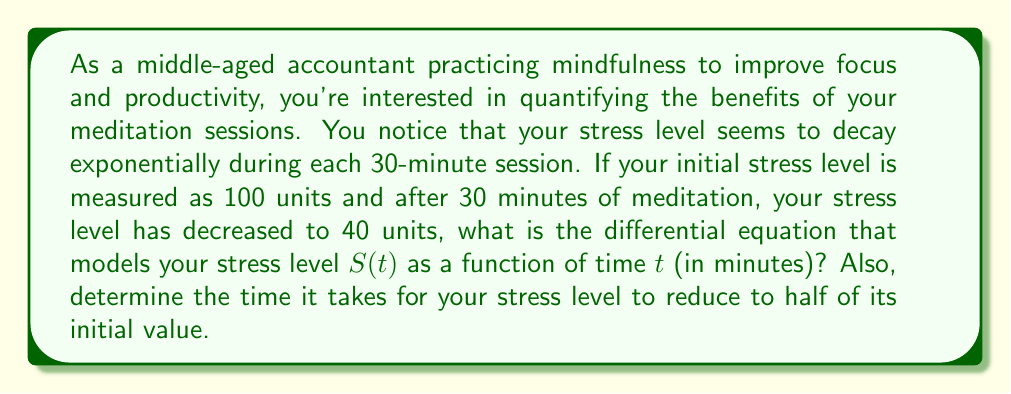Show me your answer to this math problem. Let's approach this step-by-step:

1) First, we need to recognize that this is an exponential decay problem. The general form of an exponential decay equation is:

   $$S(t) = S_0e^{-kt}$$

   where $S_0$ is the initial stress level, $k$ is the decay constant, and $t$ is time.

2) We're given two points:
   At $t = 0$, $S = 100$
   At $t = 30$, $S = 40$

3) Let's use these to find $k$:

   $$40 = 100e^{-k(30)}$$

4) Dividing both sides by 100:

   $$0.4 = e^{-30k}$$

5) Taking the natural log of both sides:

   $$\ln(0.4) = -30k$$

6) Solving for $k$:

   $$k = -\frac{\ln(0.4)}{30} \approx 0.0306$$

7) Now we can write our differential equation. The rate of change of stress is proportional to the current stress level:

   $$\frac{dS}{dt} = -kS = -0.0306S$$

8) To find the time it takes for the stress level to reduce to half its initial value, we can use the half-life formula:

   $$t_{1/2} = \frac{\ln(2)}{k} = \frac{\ln(2)}{0.0306} \approx 22.65$$
Answer: The differential equation modeling the stress level is:

$$\frac{dS}{dt} = -0.0306S$$

The time it takes for the stress level to reduce to half of its initial value is approximately 22.65 minutes. 